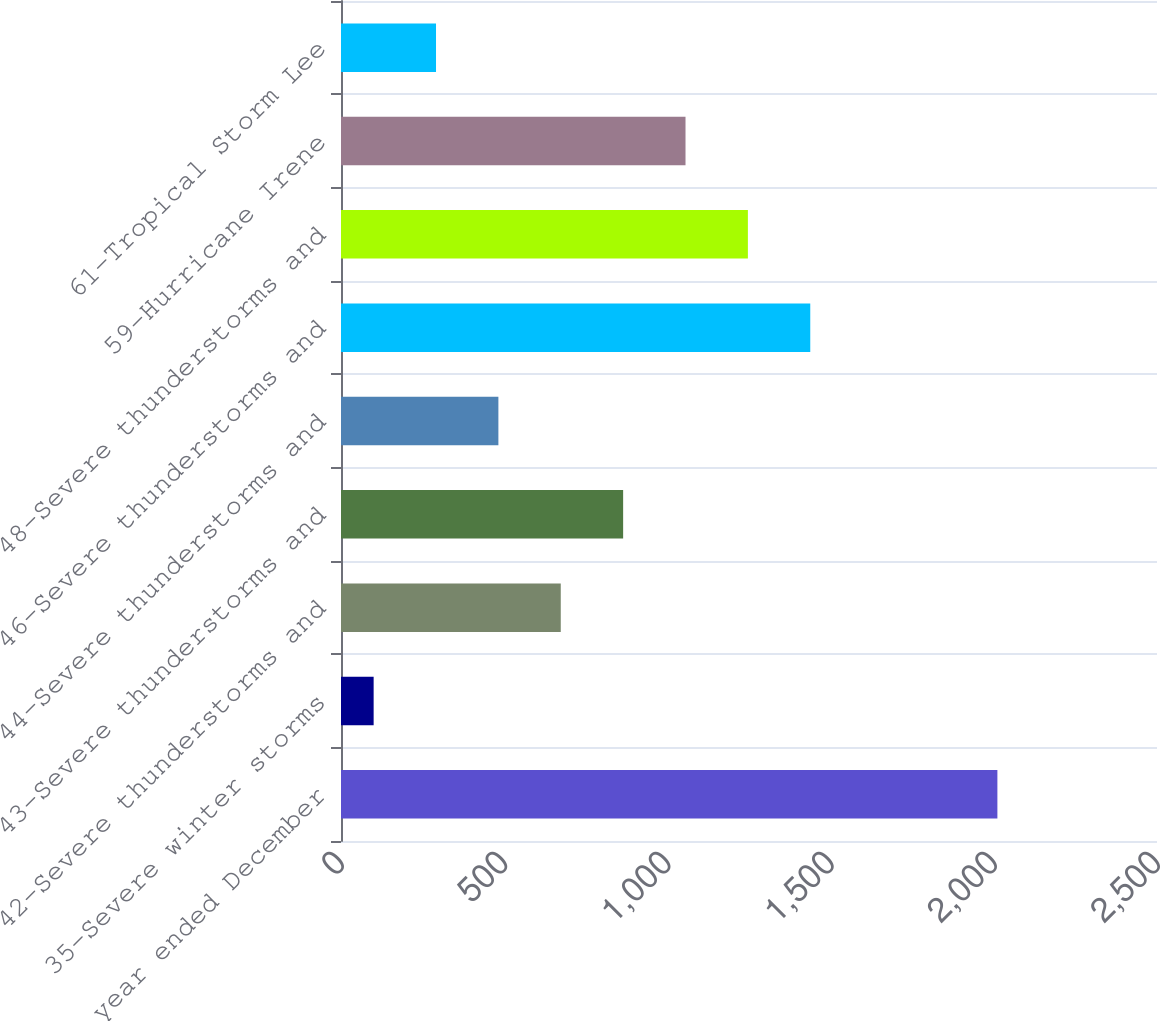Convert chart. <chart><loc_0><loc_0><loc_500><loc_500><bar_chart><fcel>(for the year ended December<fcel>35-Severe winter storms<fcel>42-Severe thunderstorms and<fcel>43-Severe thunderstorms and<fcel>44-Severe thunderstorms and<fcel>46-Severe thunderstorms and<fcel>48-Severe thunderstorms and<fcel>59-Hurricane Irene<fcel>61-Tropical Storm Lee<nl><fcel>2011<fcel>100<fcel>673.3<fcel>864.4<fcel>482.2<fcel>1437.7<fcel>1246.6<fcel>1055.5<fcel>291.1<nl></chart> 